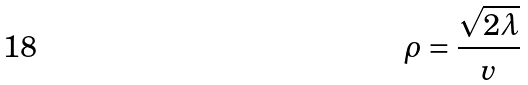<formula> <loc_0><loc_0><loc_500><loc_500>\rho = \frac { \sqrt { 2 \lambda } } { v }</formula> 